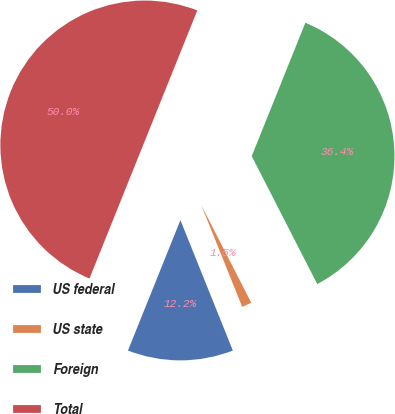Convert chart. <chart><loc_0><loc_0><loc_500><loc_500><pie_chart><fcel>US federal<fcel>US state<fcel>Foreign<fcel>Total<nl><fcel>12.17%<fcel>1.45%<fcel>36.38%<fcel>50.0%<nl></chart> 